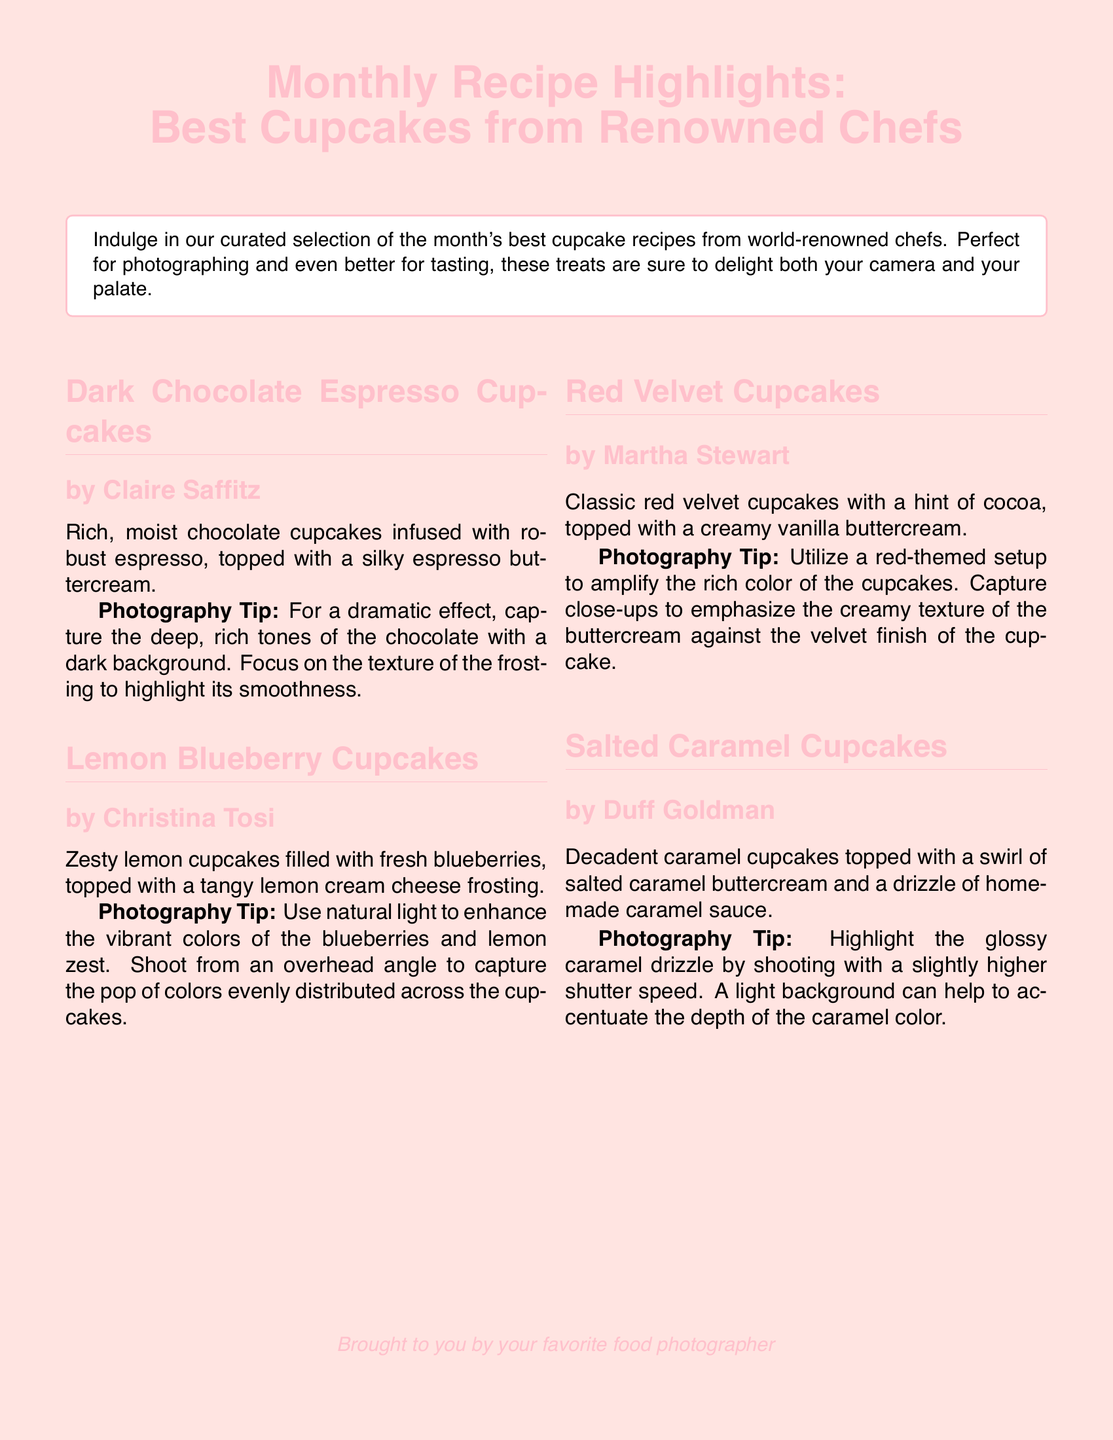What is the title of the document? The title is prominently displayed at the top of the document, indicating the focus on cupcake recipes.
Answer: Monthly Recipe Highlights: Best Cupcakes from Renowned Chefs Who is the chef of the Dark Chocolate Espresso Cupcakes? The document lists the names of the chefs next to each cupcake recipe.
Answer: Claire Saffitz What color is the background of the document? The background color is specified in the document settings, creating a soft, warm atmosphere.
Answer: Pink What is the main ingredient in the Lemon Blueberry Cupcakes? The description highlights the key flavor element of the cupcakes.
Answer: Lemon Which cupcake is topped with salted caramel buttercream? The document describes the ingredients for each cupcake, highlighting unique toppings.
Answer: Salted Caramel Cupcakes What photography tip is suggested for capturing the Red Velvet Cupcakes? The document provides specific advice for photographing each cupcake type.
Answer: Close-ups to emphasize creamy texture How many chefs are featured in the document? The document lists a total of four different cupcake recipes, each with a chef.
Answer: Four What type of frosting is used on the Red Velvet Cupcakes? The text specifies the type of buttercream that complements the cupcakes.
Answer: Vanilla buttercream What is the primary flavor of the Salted Caramel Cupcakes? The description indicates the key flavor that defines the cupcakes.
Answer: Caramel 